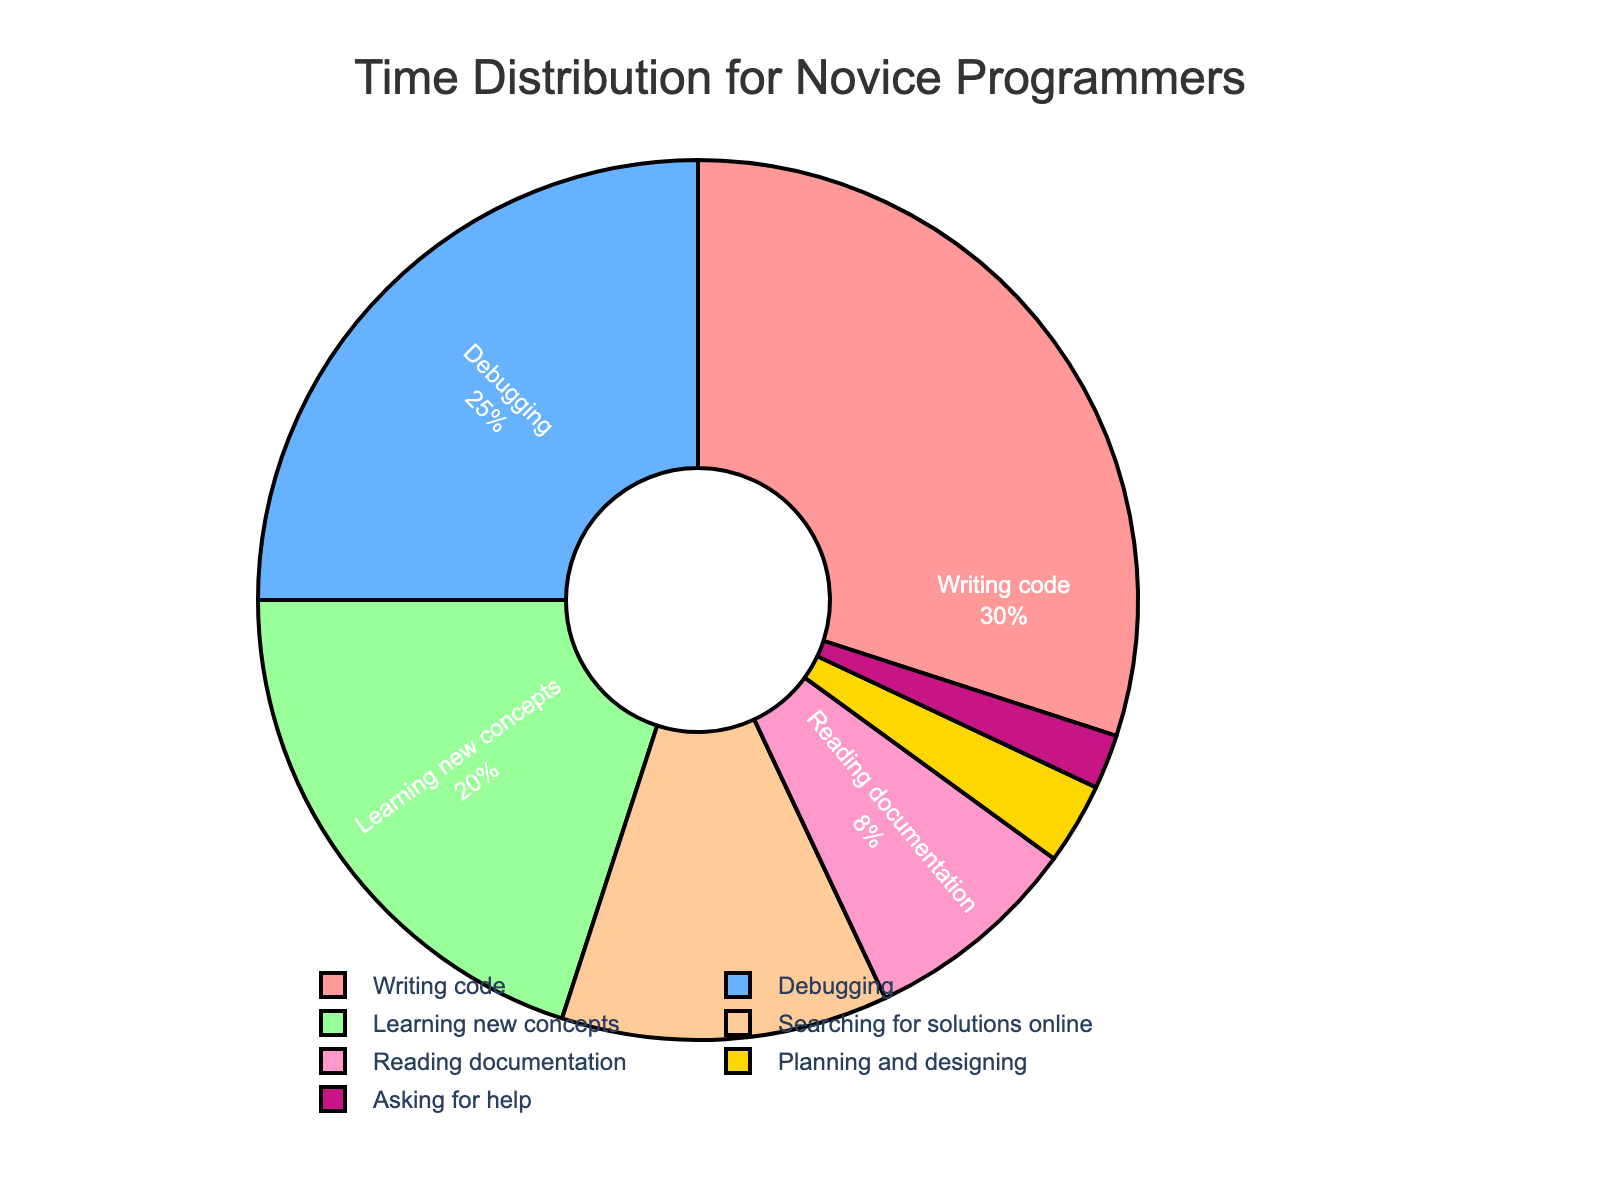what proportion of time do novice programmers spend on reading documentation compared to writing code? Based on the pie chart, the percentage of time spent on reading documentation is 8%, and writing code is 30%. The proportion is calculated by dividing the time spent reading documentation by the time spent writing code: 8 / 30 ≈ 0.267.
Answer: 0.267 which activities take up more time than learning new concepts? The activities that consume more time according to the pie chart are writing code (30%) and debugging (25%). Both are higher than the 20% spent on learning new concepts.
Answer: writing code, debugging if you sum up the time spent on planning and designing, reading documentation, and asking for help, what is the total percentage? The pie chart indicates that planning and designing takes up 3%, reading documentation 8%, and asking for help 2%. Adding these up: 3 + 8 + 2 = 13%.
Answer: 13% what is the least time-consuming activity for novice programmers according to the chart? The pie chart shows that asking for help takes up the least time, which is 2%.
Answer: asking for help how much more time is spent on debugging compared to searching for solutions online? Debugging accounts for 25% of the time, while searching for solutions online accounts for 12%. The difference is 25% - 12% = 13%.
Answer: 13% determine the average percentage of time spent on writing code, learning new concepts, and debugging. The percentages are writing code (30%), learning new concepts (20%), and debugging (25%). The average is calculated as (30 + 20 + 25) / 3 = 75 / 3 = 25%.
Answer: 25% is the time spent on planning and designing more or less than the time spent on asking for help? The pie chart shows that planning and designing takes up 3% of the time, while asking for help takes up 2%. So, more time is spent on planning and designing.
Answer: more which activity has the closest time percentage to learning new concepts? Learning new concepts takes up 20% of the time. Debugging, which takes up 25% of the time, is the closest in percentage.
Answer: debugging what percentage of time is spent on activities other than writing code and debugging? Writing code takes up 30% and debugging takes up 25%, summing these gives 55%. The remaining time is 100% - 55% = 45%.
Answer: 45% if the time spent searching for solutions online increased by 5%, how would it compare to the time spent on learning new concepts? Currently, searching for solutions online takes up 12%. If it increases by 5%, it becomes 12% + 5% = 17%. This is still less than the 20% spent on learning new concepts.
Answer: less 